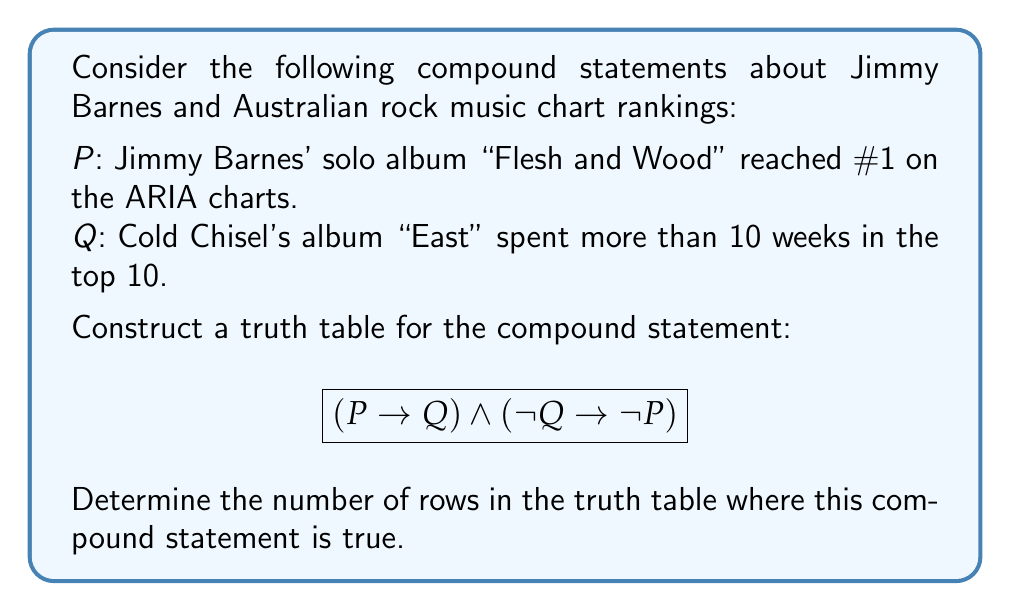Solve this math problem. Let's approach this step-by-step:

1) First, we need to construct the truth table. It will have 4 rows (2^2) since there are 2 simple statements (P and Q).

2) We'll evaluate the following:
   a) $P \rightarrow Q$
   b) $\lnot Q \rightarrow \lnot P$
   c) $(P \rightarrow Q) \land (\lnot Q \rightarrow \lnot P)$

3) Here's the truth table:

   | P | Q | $P \rightarrow Q$ | $\lnot Q$ | $\lnot P$ | $\lnot Q \rightarrow \lnot P$ | $(P \rightarrow Q) \land (\lnot Q \rightarrow \lnot P)$ |
   |---|---|-------------------|-----------|-----------|--------------------------------|--------------------------------------------------------|
   | T | T | T                 | F         | F         | T                              | T                                                      |
   | T | F | F                 | T         | F         | F                              | F                                                      |
   | F | T | T                 | F         | T         | T                              | T                                                      |
   | F | F | T                 | T         | T         | T                              | T                                                      |

4) Explanation of each column:
   - $P \rightarrow Q$ is false only when P is true and Q is false.
   - $\lnot Q \rightarrow \lnot P$ is equivalent to $Q \lor \lnot P$, which is false only when Q is false and P is true.

5) The final column shows the result of the entire compound statement.

6) Counting the number of true values in the final column, we see that the compound statement is true in 3 rows.
Answer: 3 